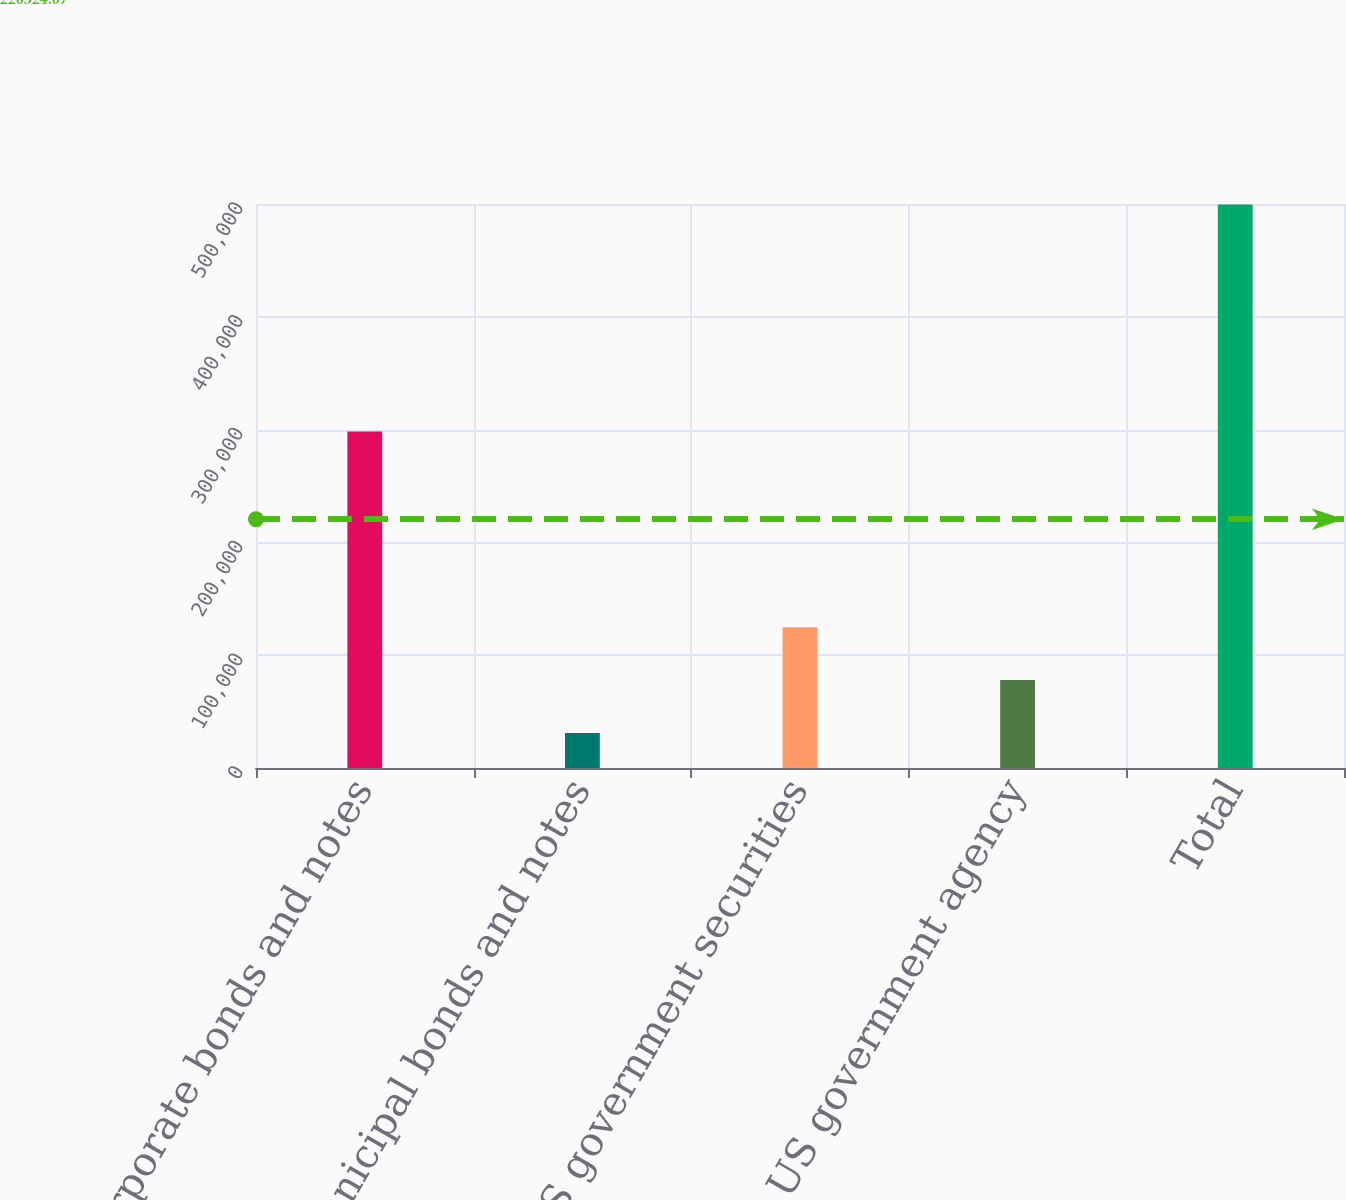Convert chart to OTSL. <chart><loc_0><loc_0><loc_500><loc_500><bar_chart><fcel>Corporate bonds and notes<fcel>Municipal bonds and notes<fcel>US government securities<fcel>US government agency<fcel>Total<nl><fcel>298253<fcel>31137<fcel>124823<fcel>77979.8<fcel>499565<nl></chart> 